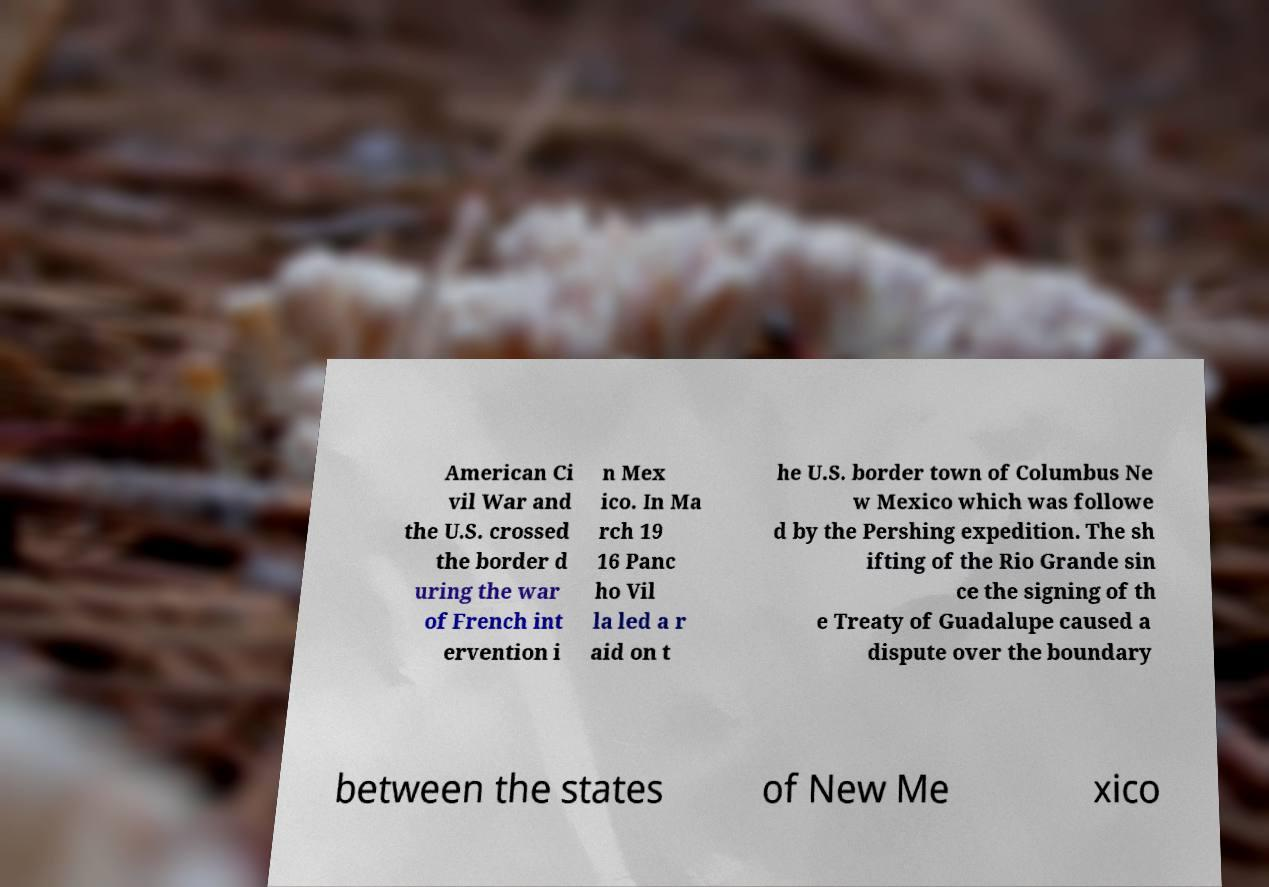I need the written content from this picture converted into text. Can you do that? American Ci vil War and the U.S. crossed the border d uring the war of French int ervention i n Mex ico. In Ma rch 19 16 Panc ho Vil la led a r aid on t he U.S. border town of Columbus Ne w Mexico which was followe d by the Pershing expedition. The sh ifting of the Rio Grande sin ce the signing of th e Treaty of Guadalupe caused a dispute over the boundary between the states of New Me xico 